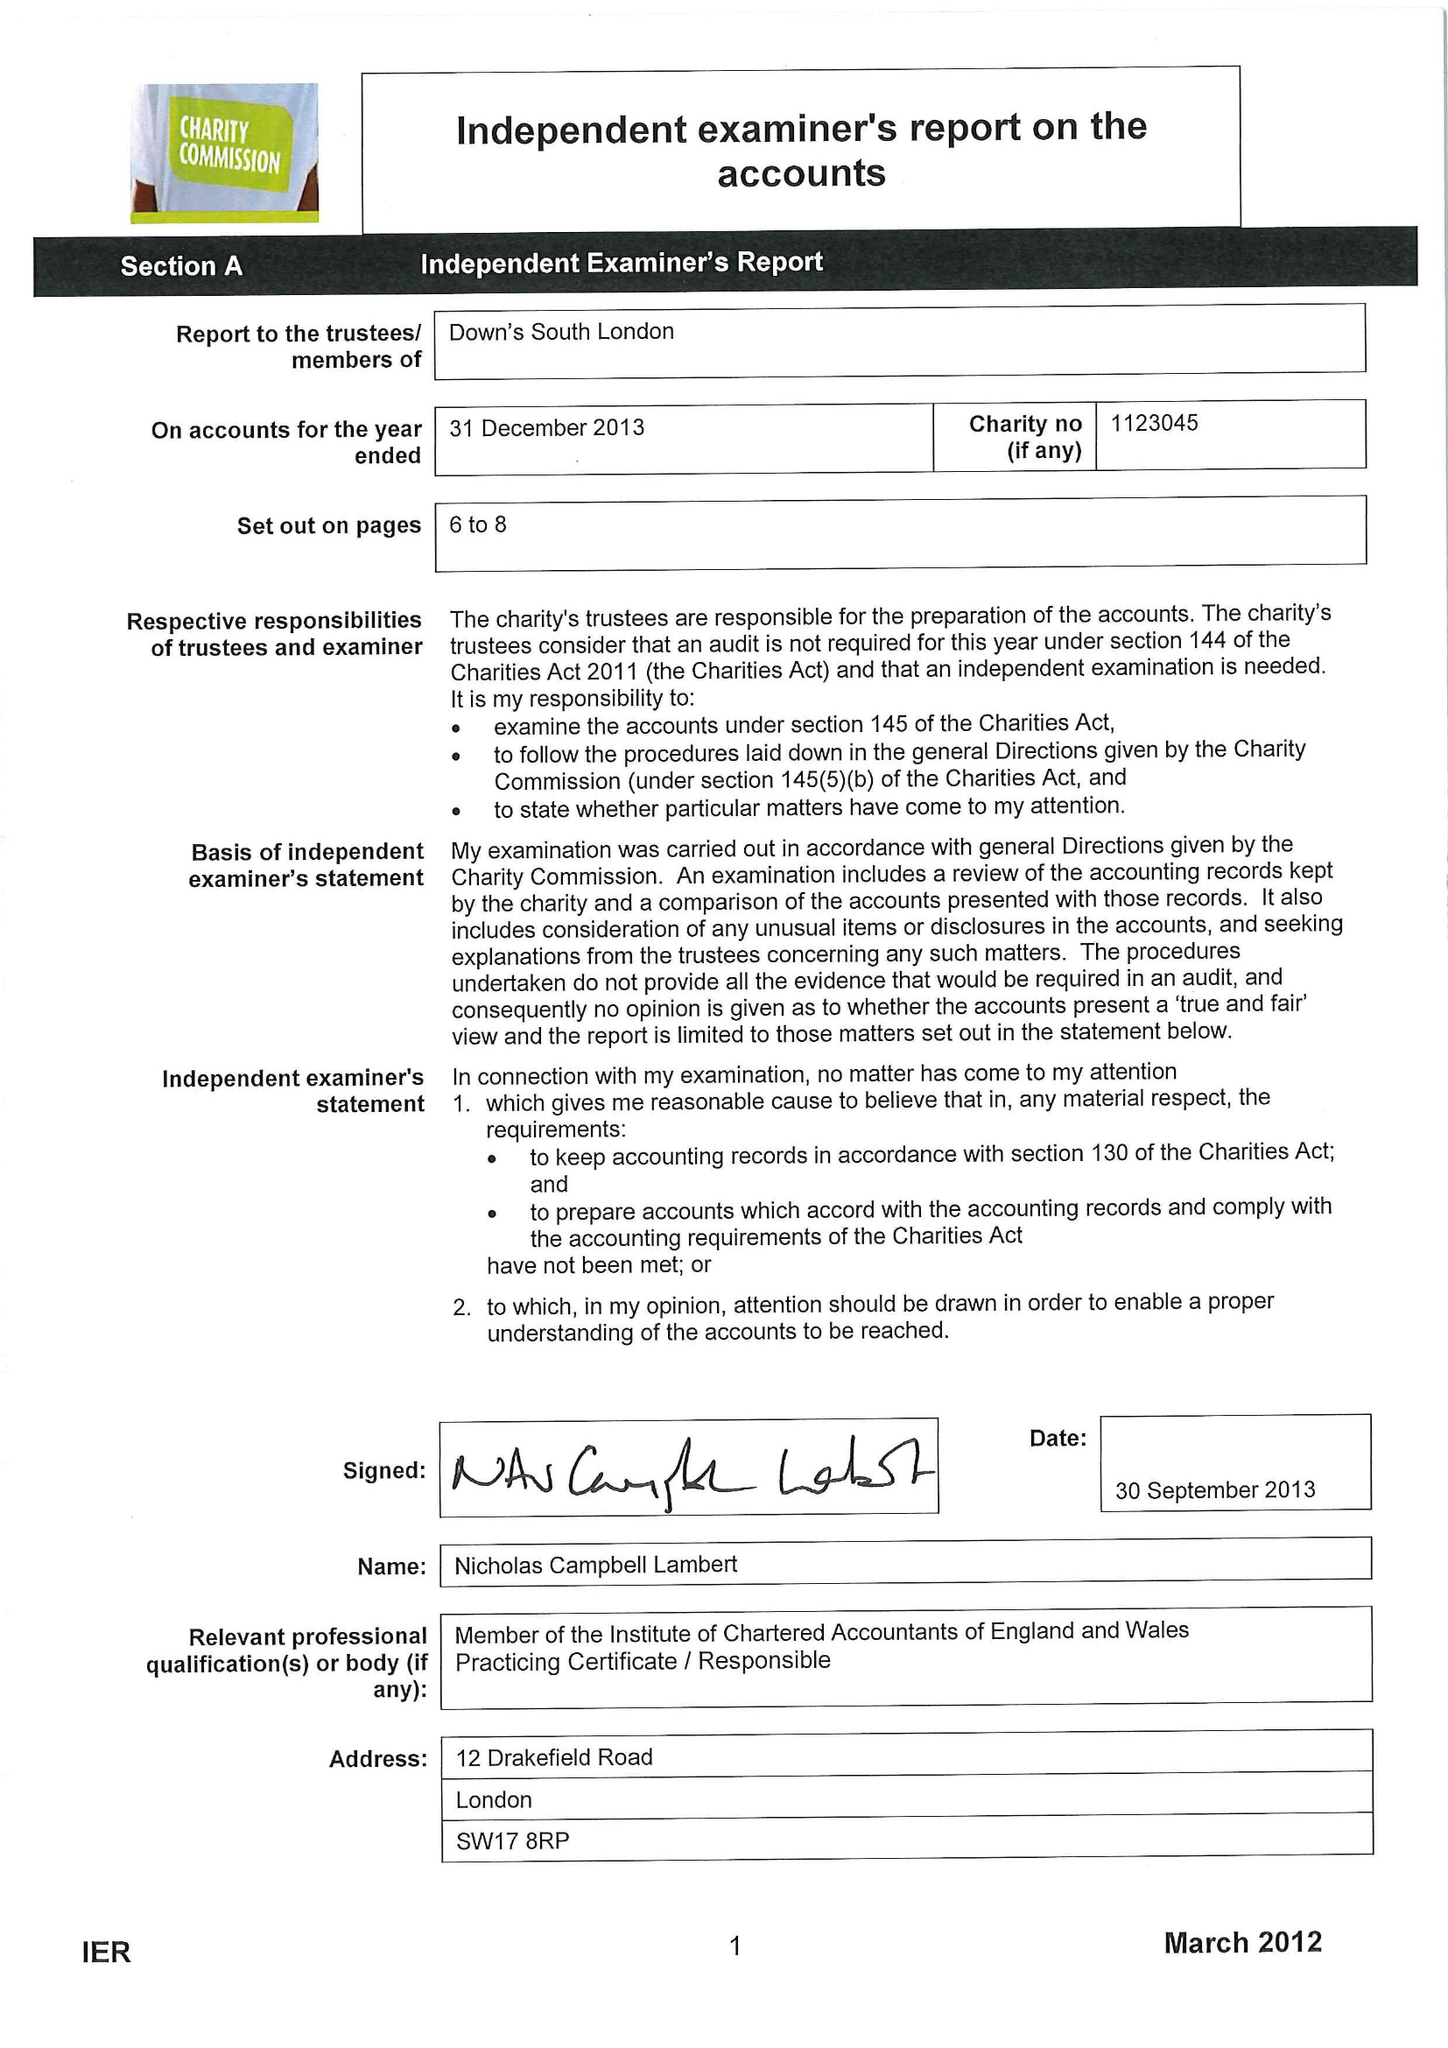What is the value for the spending_annually_in_british_pounds?
Answer the question using a single word or phrase. 107392.00 